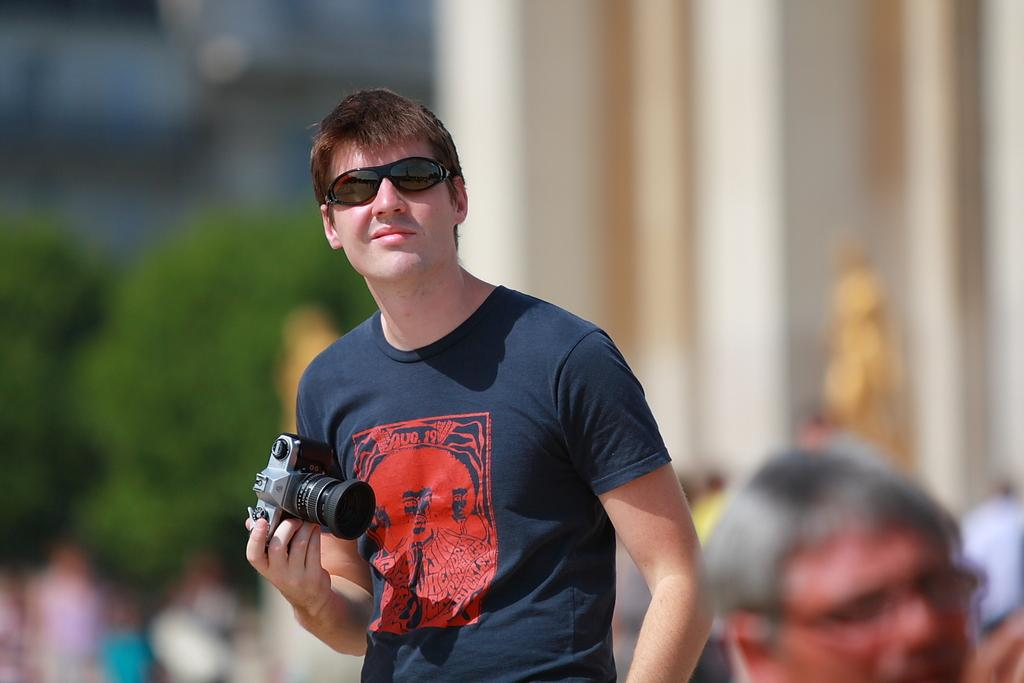Who is present in the image? There is a man in the image. What is the man doing in the image? The man is standing in the image. What can be seen on the man's face? The man is wearing glasses in the image. What is the man holding in the image? The man is holding a camera in the image. What can be observed about the background of the image? The background of the image is blurred. What type of writing can be seen on the man's shirt in the image? There is no writing visible on the man's shirt in the image. How many dogs are present in the image? There are no dogs present in the image. 